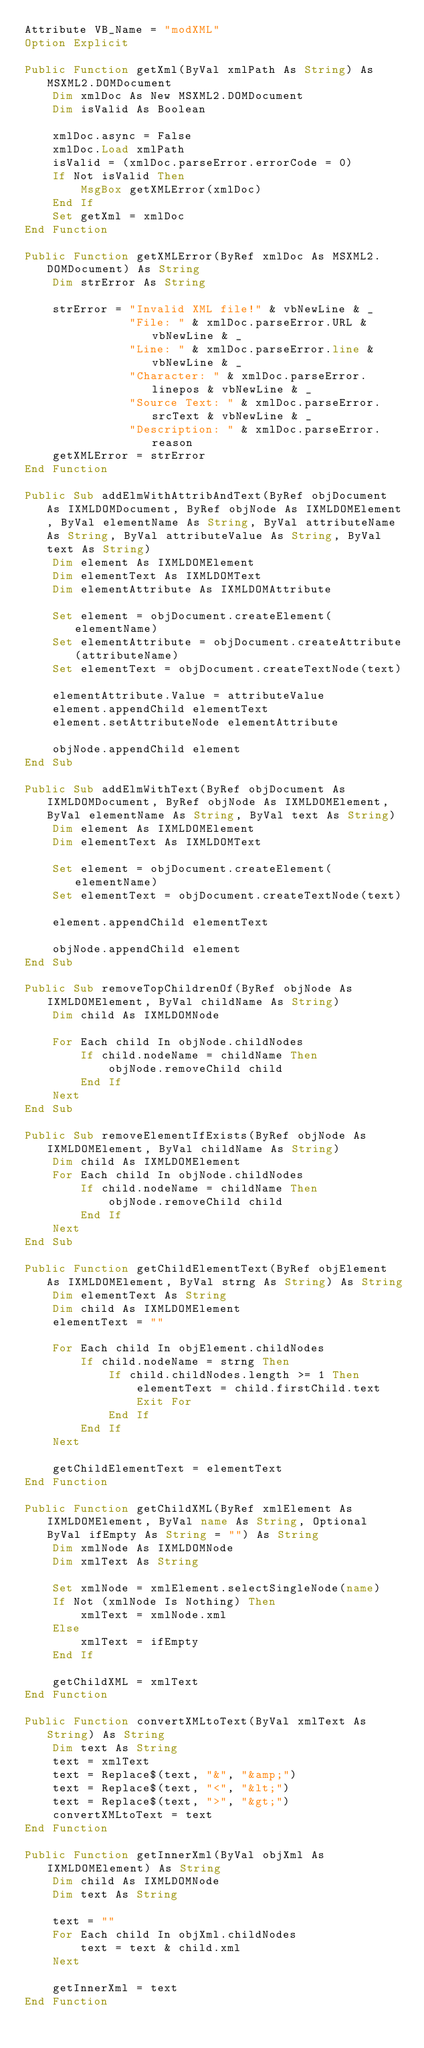Convert code to text. <code><loc_0><loc_0><loc_500><loc_500><_VisualBasic_>Attribute VB_Name = "modXML"
Option Explicit

Public Function getXml(ByVal xmlPath As String) As MSXML2.DOMDocument
    Dim xmlDoc As New MSXML2.DOMDocument
    Dim isValid As Boolean
    
    xmlDoc.async = False
    xmlDoc.Load xmlPath
    isValid = (xmlDoc.parseError.errorCode = 0)
    If Not isValid Then
        MsgBox getXMLError(xmlDoc)
    End If
    Set getXml = xmlDoc
End Function

Public Function getXMLError(ByRef xmlDoc As MSXML2.DOMDocument) As String
    Dim strError As String
    
    strError = "Invalid XML file!" & vbNewLine & _
               "File: " & xmlDoc.parseError.URL & vbNewLine & _
               "Line: " & xmlDoc.parseError.line & vbNewLine & _
               "Character: " & xmlDoc.parseError.linepos & vbNewLine & _
               "Source Text: " & xmlDoc.parseError.srcText & vbNewLine & _
               "Description: " & xmlDoc.parseError.reason
    getXMLError = strError
End Function

Public Sub addElmWithAttribAndText(ByRef objDocument As IXMLDOMDocument, ByRef objNode As IXMLDOMElement, ByVal elementName As String, ByVal attributeName As String, ByVal attributeValue As String, ByVal text As String)
    Dim element As IXMLDOMElement
    Dim elementText As IXMLDOMText
    Dim elementAttribute As IXMLDOMAttribute
    
    Set element = objDocument.createElement(elementName)
    Set elementAttribute = objDocument.createAttribute(attributeName)
    Set elementText = objDocument.createTextNode(text)
    
    elementAttribute.Value = attributeValue
    element.appendChild elementText
    element.setAttributeNode elementAttribute
    
    objNode.appendChild element
End Sub

Public Sub addElmWithText(ByRef objDocument As IXMLDOMDocument, ByRef objNode As IXMLDOMElement, ByVal elementName As String, ByVal text As String)
    Dim element As IXMLDOMElement
    Dim elementText As IXMLDOMText
    
    Set element = objDocument.createElement(elementName)
    Set elementText = objDocument.createTextNode(text)
    
    element.appendChild elementText
    
    objNode.appendChild element
End Sub

Public Sub removeTopChildrenOf(ByRef objNode As IXMLDOMElement, ByVal childName As String)
    Dim child As IXMLDOMNode

    For Each child In objNode.childNodes
        If child.nodeName = childName Then
            objNode.removeChild child
        End If
    Next
End Sub

Public Sub removeElementIfExists(ByRef objNode As IXMLDOMElement, ByVal childName As String)
    Dim child As IXMLDOMElement
    For Each child In objNode.childNodes
        If child.nodeName = childName Then
            objNode.removeChild child
        End If
    Next
End Sub

Public Function getChildElementText(ByRef objElement As IXMLDOMElement, ByVal strng As String) As String
    Dim elementText As String
    Dim child As IXMLDOMElement
    elementText = ""
    
    For Each child In objElement.childNodes
        If child.nodeName = strng Then
            If child.childNodes.length >= 1 Then
                elementText = child.firstChild.text
                Exit For
            End If
        End If
    Next
    
    getChildElementText = elementText
End Function

Public Function getChildXML(ByRef xmlElement As IXMLDOMElement, ByVal name As String, Optional ByVal ifEmpty As String = "") As String
    Dim xmlNode As IXMLDOMNode
    Dim xmlText As String
    
    Set xmlNode = xmlElement.selectSingleNode(name)
    If Not (xmlNode Is Nothing) Then
        xmlText = xmlNode.xml
    Else
        xmlText = ifEmpty
    End If
    
    getChildXML = xmlText
End Function

Public Function convertXMLtoText(ByVal xmlText As String) As String
    Dim text As String
    text = xmlText
    text = Replace$(text, "&", "&amp;")
    text = Replace$(text, "<", "&lt;")
    text = Replace$(text, ">", "&gt;")
    convertXMLtoText = text
End Function

Public Function getInnerXml(ByVal objXml As IXMLDOMElement) As String
    Dim child As IXMLDOMNode
    Dim text As String
    
    text = ""
    For Each child In objXml.childNodes
        text = text & child.xml
    Next
    
    getInnerXml = text
End Function
</code> 